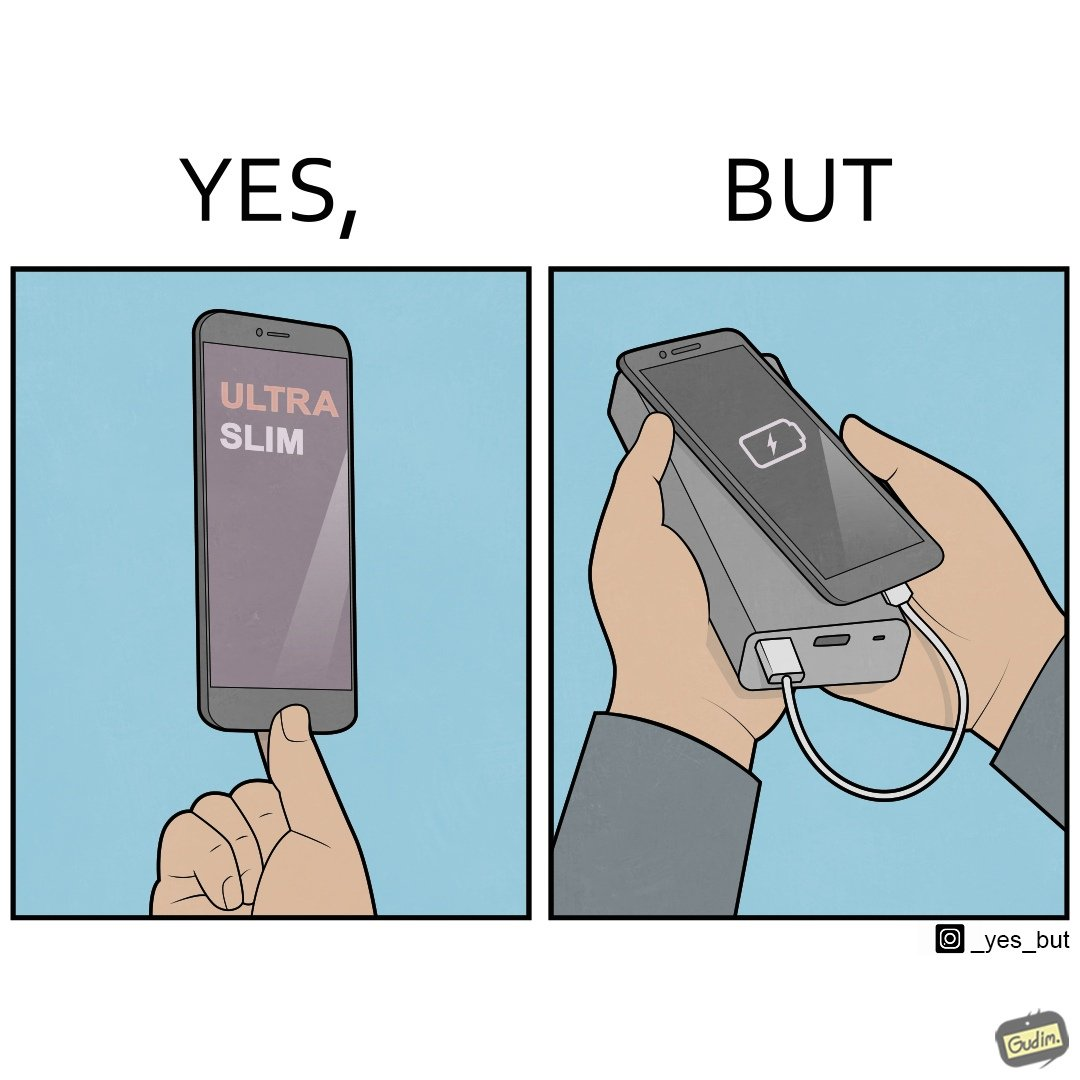Explain the humor or irony in this image. The image is satirical because even though the mobile phone has been developed to be very slim, it requires frequent recharging which makes the mobile phone useless without a big, heavy and thick power bank. 